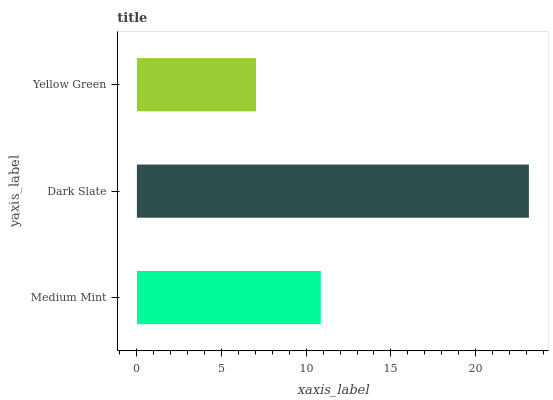Is Yellow Green the minimum?
Answer yes or no. Yes. Is Dark Slate the maximum?
Answer yes or no. Yes. Is Dark Slate the minimum?
Answer yes or no. No. Is Yellow Green the maximum?
Answer yes or no. No. Is Dark Slate greater than Yellow Green?
Answer yes or no. Yes. Is Yellow Green less than Dark Slate?
Answer yes or no. Yes. Is Yellow Green greater than Dark Slate?
Answer yes or no. No. Is Dark Slate less than Yellow Green?
Answer yes or no. No. Is Medium Mint the high median?
Answer yes or no. Yes. Is Medium Mint the low median?
Answer yes or no. Yes. Is Dark Slate the high median?
Answer yes or no. No. Is Yellow Green the low median?
Answer yes or no. No. 